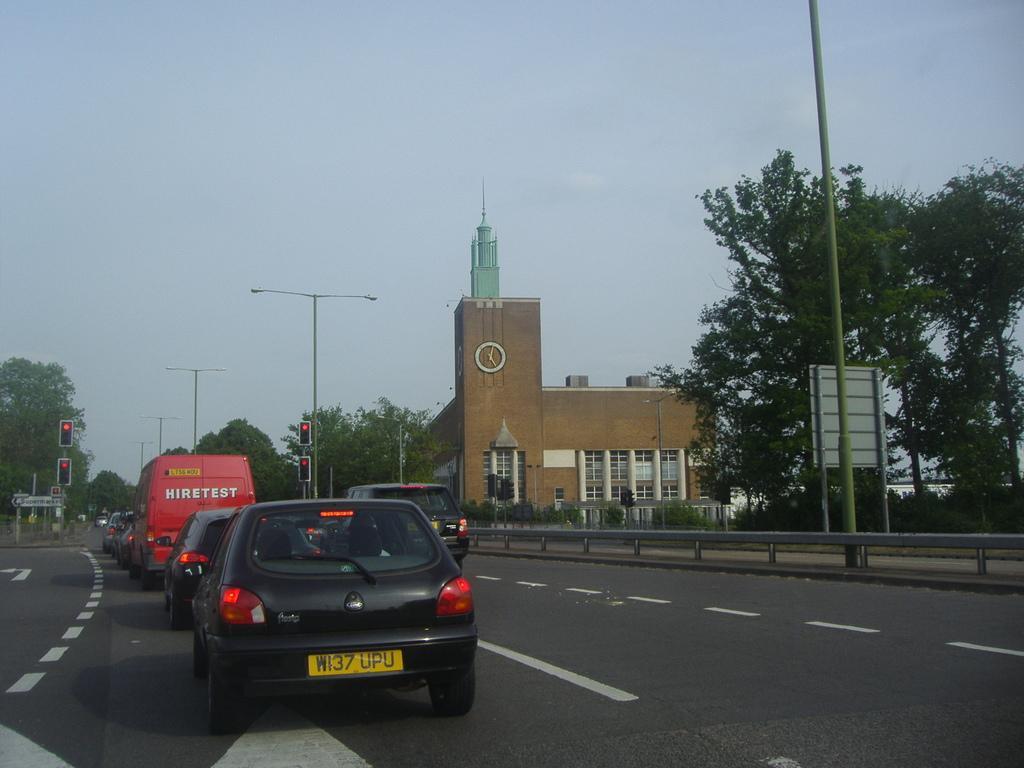In one or two sentences, can you explain what this image depicts? This is the picture of a city. In this image there are vehicles on the road. At the back there are buildings, trees and poles and there is a clock on the building. On the right side of the image there is a railing beside the road. At the top there is sky. At the bottom there is a road. 